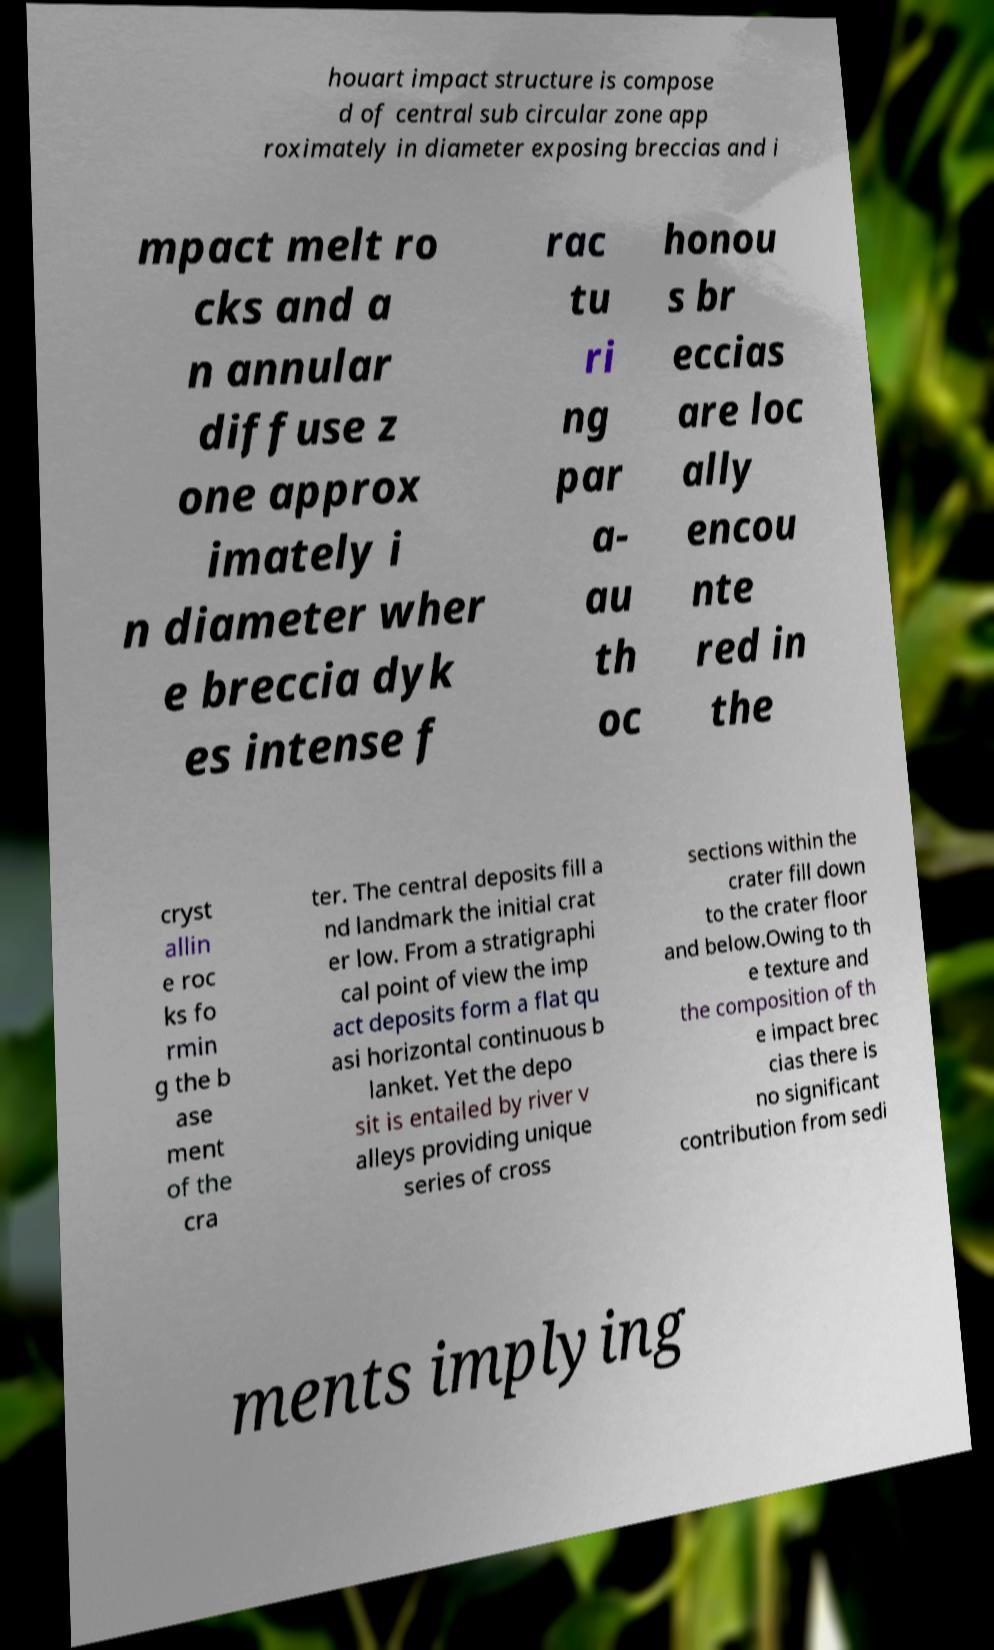For documentation purposes, I need the text within this image transcribed. Could you provide that? houart impact structure is compose d of central sub circular zone app roximately in diameter exposing breccias and i mpact melt ro cks and a n annular diffuse z one approx imately i n diameter wher e breccia dyk es intense f rac tu ri ng par a- au th oc honou s br eccias are loc ally encou nte red in the cryst allin e roc ks fo rmin g the b ase ment of the cra ter. The central deposits fill a nd landmark the initial crat er low. From a stratigraphi cal point of view the imp act deposits form a flat qu asi horizontal continuous b lanket. Yet the depo sit is entailed by river v alleys providing unique series of cross sections within the crater fill down to the crater floor and below.Owing to th e texture and the composition of th e impact brec cias there is no significant contribution from sedi ments implying 